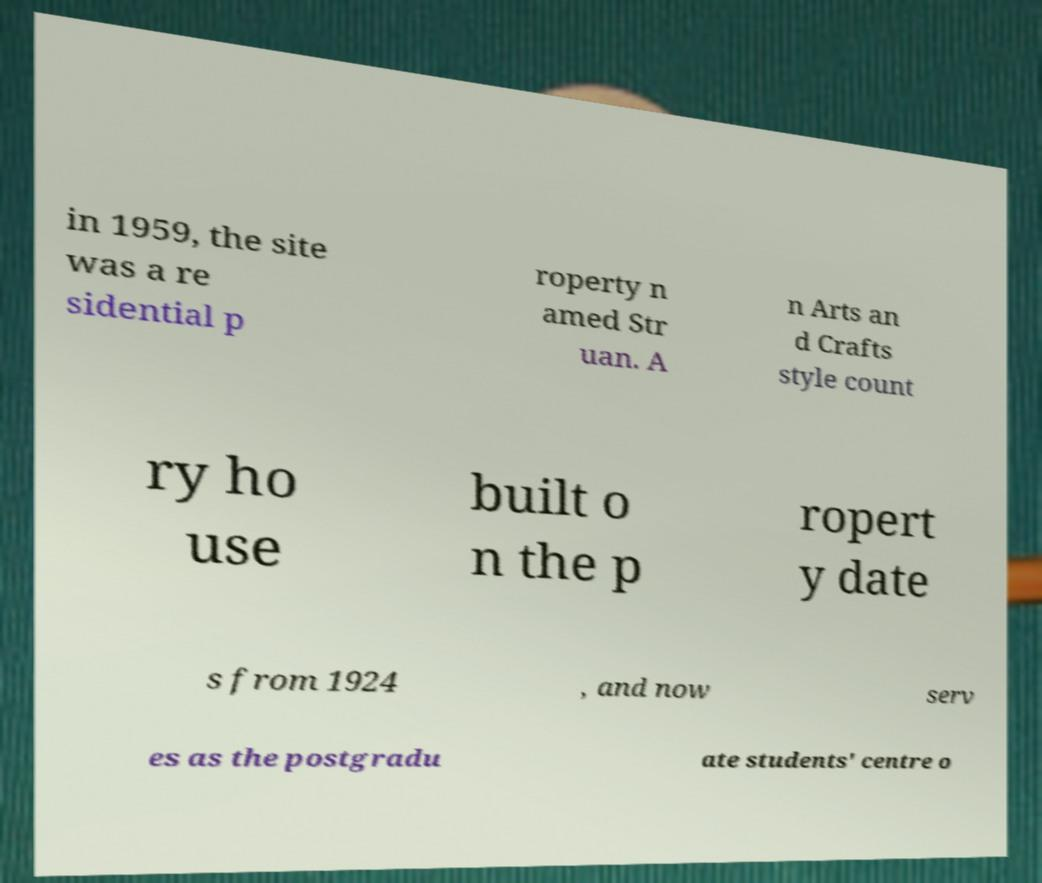I need the written content from this picture converted into text. Can you do that? in 1959, the site was a re sidential p roperty n amed Str uan. A n Arts an d Crafts style count ry ho use built o n the p ropert y date s from 1924 , and now serv es as the postgradu ate students' centre o 